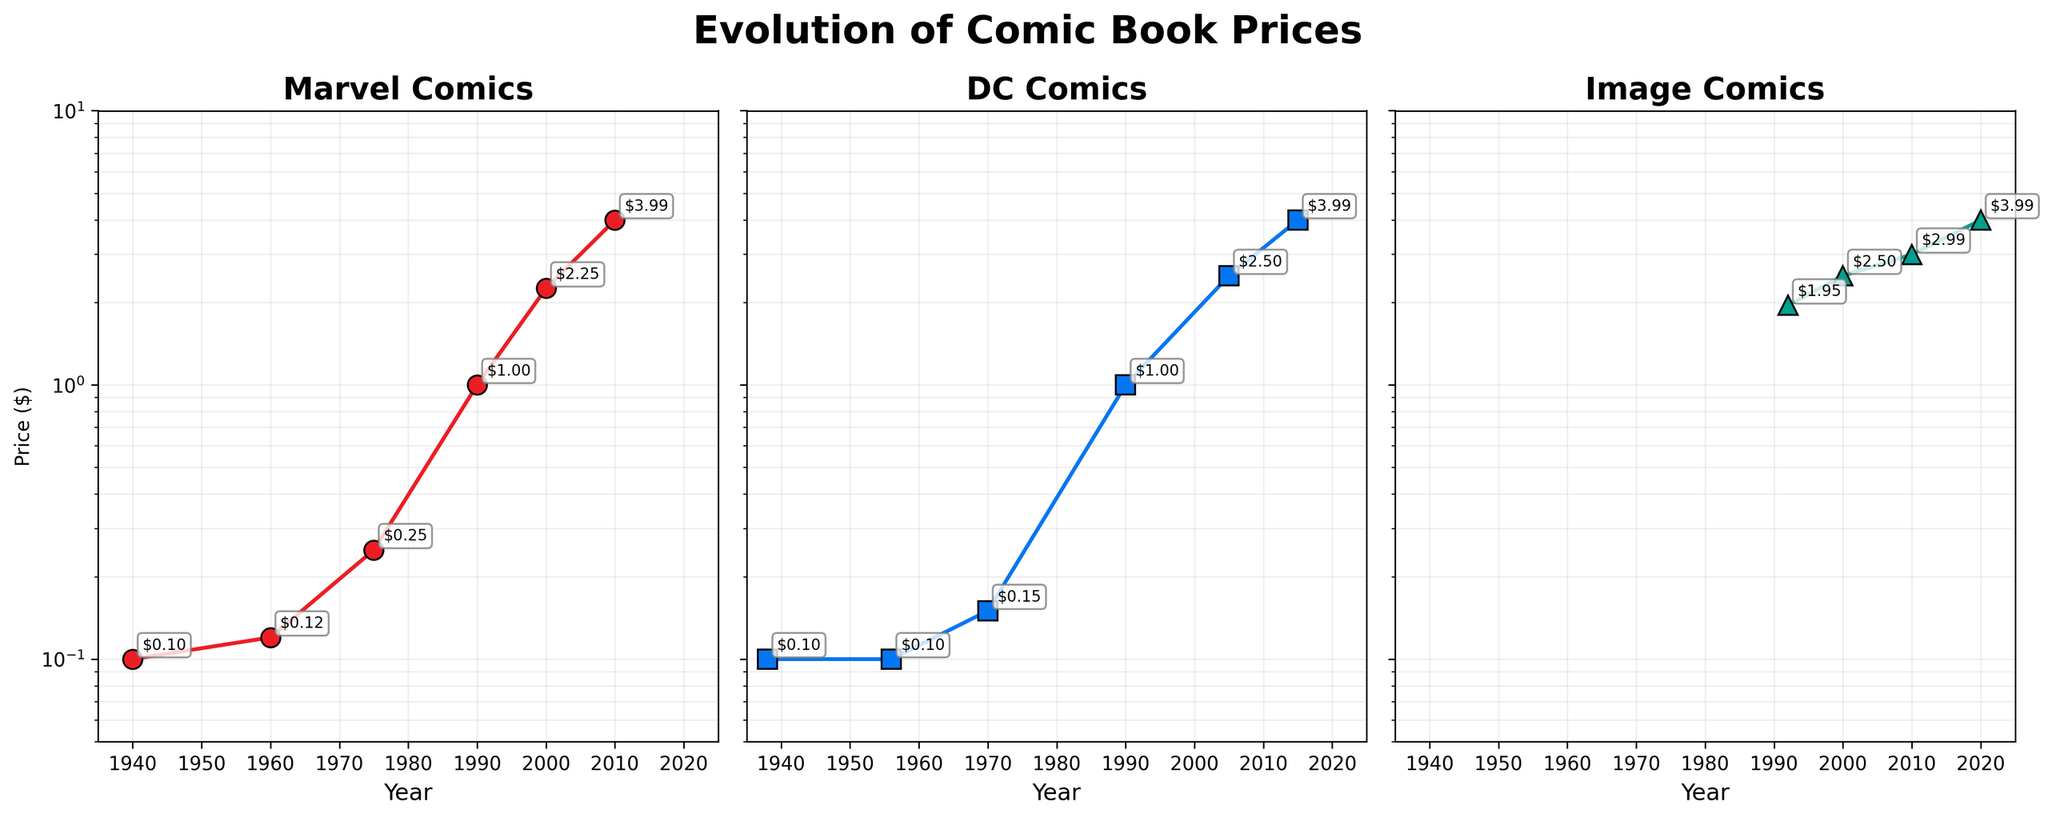What is the title of the figure? The title is usually located at the top of the figure. Upon inspection, the title reads 'Evolution of Comic Book Prices'.
Answer: Evolution of Comic Book Prices Which publisher had the highest comic book price in the year 2020? Checking the data points for each publisher in 2020, only Image Comics has the year 2020 with a price of $3.99.
Answer: Image Comics How does the price of a Marvel Comics issue in 1975 compare to a DC Comics issue in 1970? Locate the data points for Marvel Comics in 1975 ($0.25) and DC Comics in 1970 ($0.15). Compare them: $0.25 is greater than $0.15.
Answer: Marvel Comics had a higher price What is the general trend of comic book prices over the years for each publisher? Examining the plots, all publishers show that the prices generally increase steadily over time from the Golden Age to the Modern Era. This can be seen from the rising points in the log-scale subplots for each publisher.
Answer: Prices generally increase What was the price of a Marvel Comics issue in 1990? Locate the year 1990 on the Marvel Comics subplot and read off the point value, which is $1.00.
Answer: $1.00 What year did DC Comics first price their comics higher than $2.00? Check the DC Comics subplot, find the earliest year above $2.00 which is in 2005 with a price of $2.50.
Answer: 2005 Which end-of-decade year had the highest price for Image Comics? Considering the available end-of-decade years for Image Comics (1990, 2000, 2010, 2020), 2020 shows the highest price at $3.99.
Answer: 2020 How many comic book prices from DC Comics surpass $1.00 between 1990 and 2015? Inspect the DC Comics subplot, and count the prices that are higher than $1.00. In 1990, 2005, and 2015 the prices are $1.00, $2.50, and $3.99, respectively. Only two prices surpass $1.00.
Answer: 2 Compare the price increase from 1970 to 2000 for both Marvel Comics and DC Comics. Which publisher had a larger price increase? For Marvel Comics, 1970 is not present but 1975 shows $0.25 and for 2000, it is $2.25. Increase = $2.25 - $0.25 = $2.00. For DC Comics, from $0.15 (1970) to $2.50 (2000), the increase is $2.35. DC Comics had a higher increase.
Answer: DC Comics What is the price difference between a Marvel and DC Comics issue in the year 1990? Locate the year 1990 on both subplots. Marvel Comics has a price of $1.00 and DC Comics has a price of $1.00 as well. The difference is $1.00 - $1.00.
Answer: $0.00 